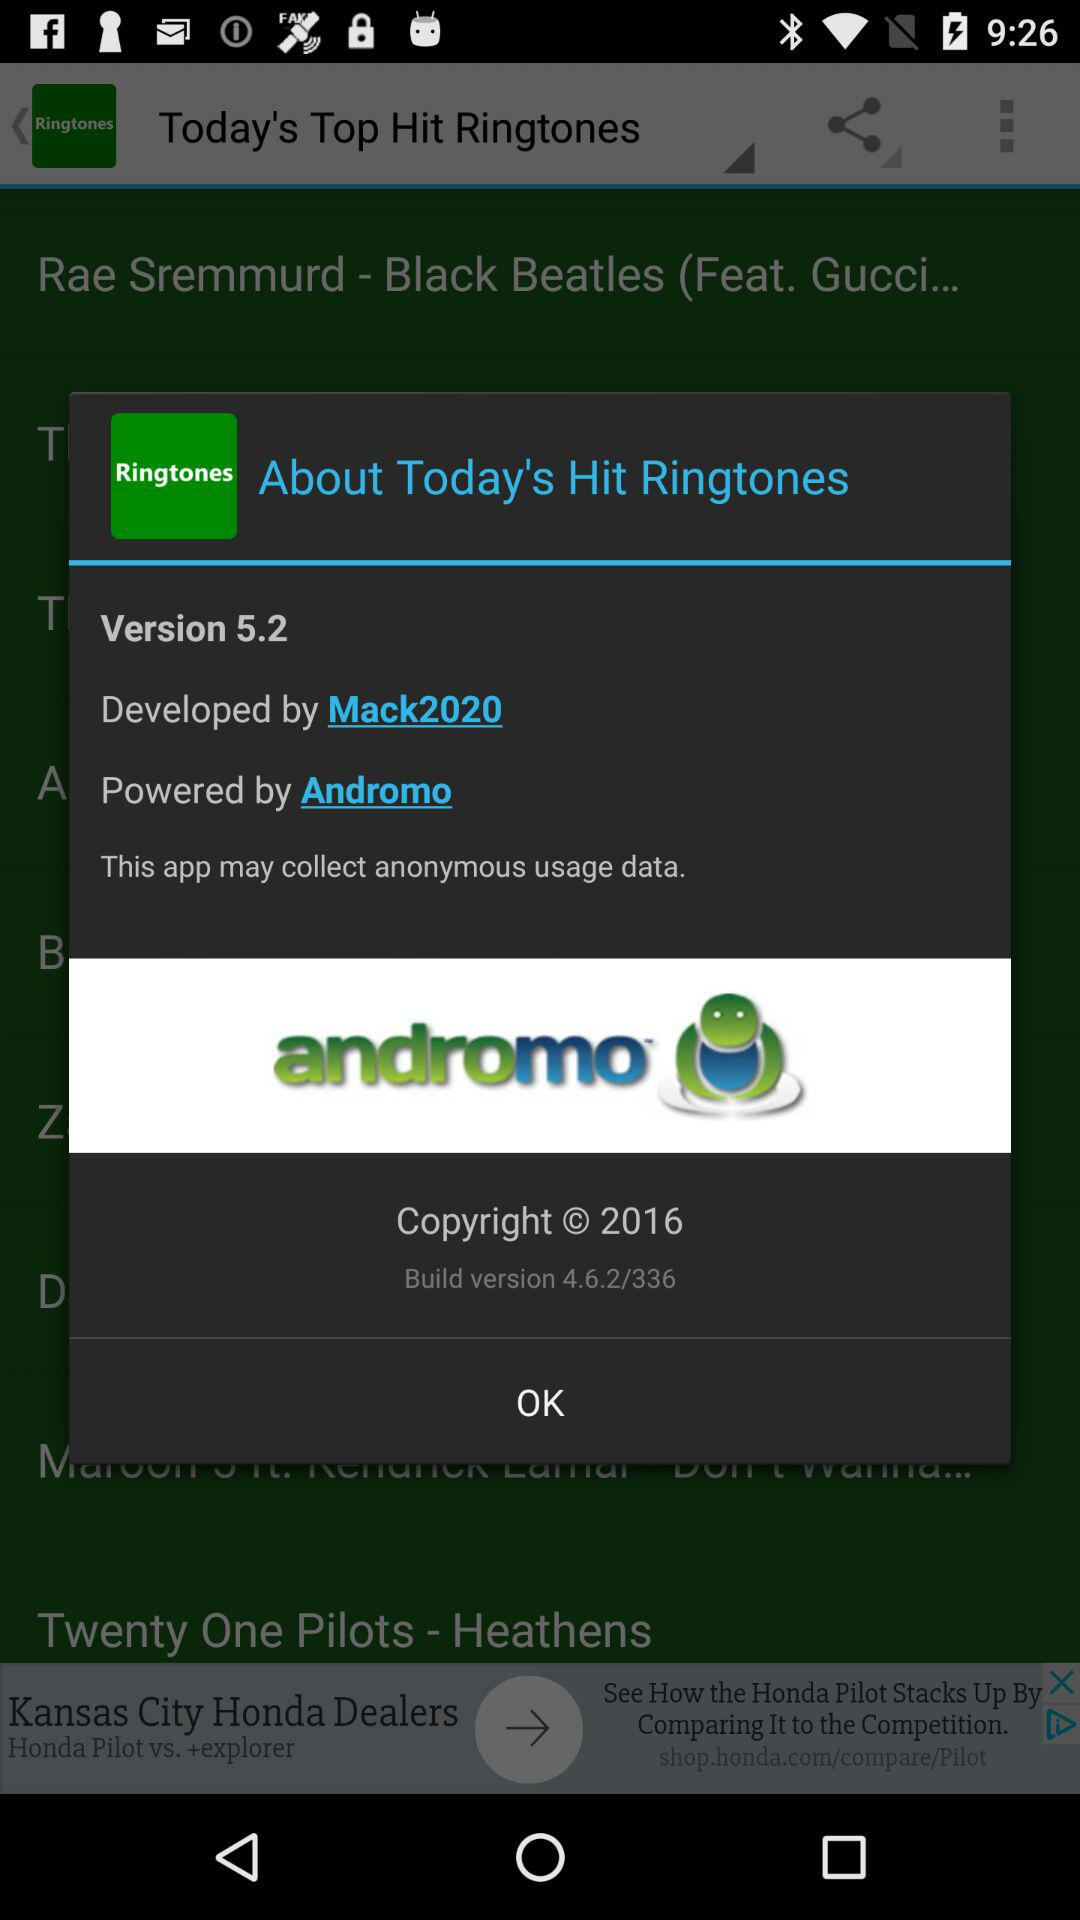What is the copyright year? The copyright year is 2016. 